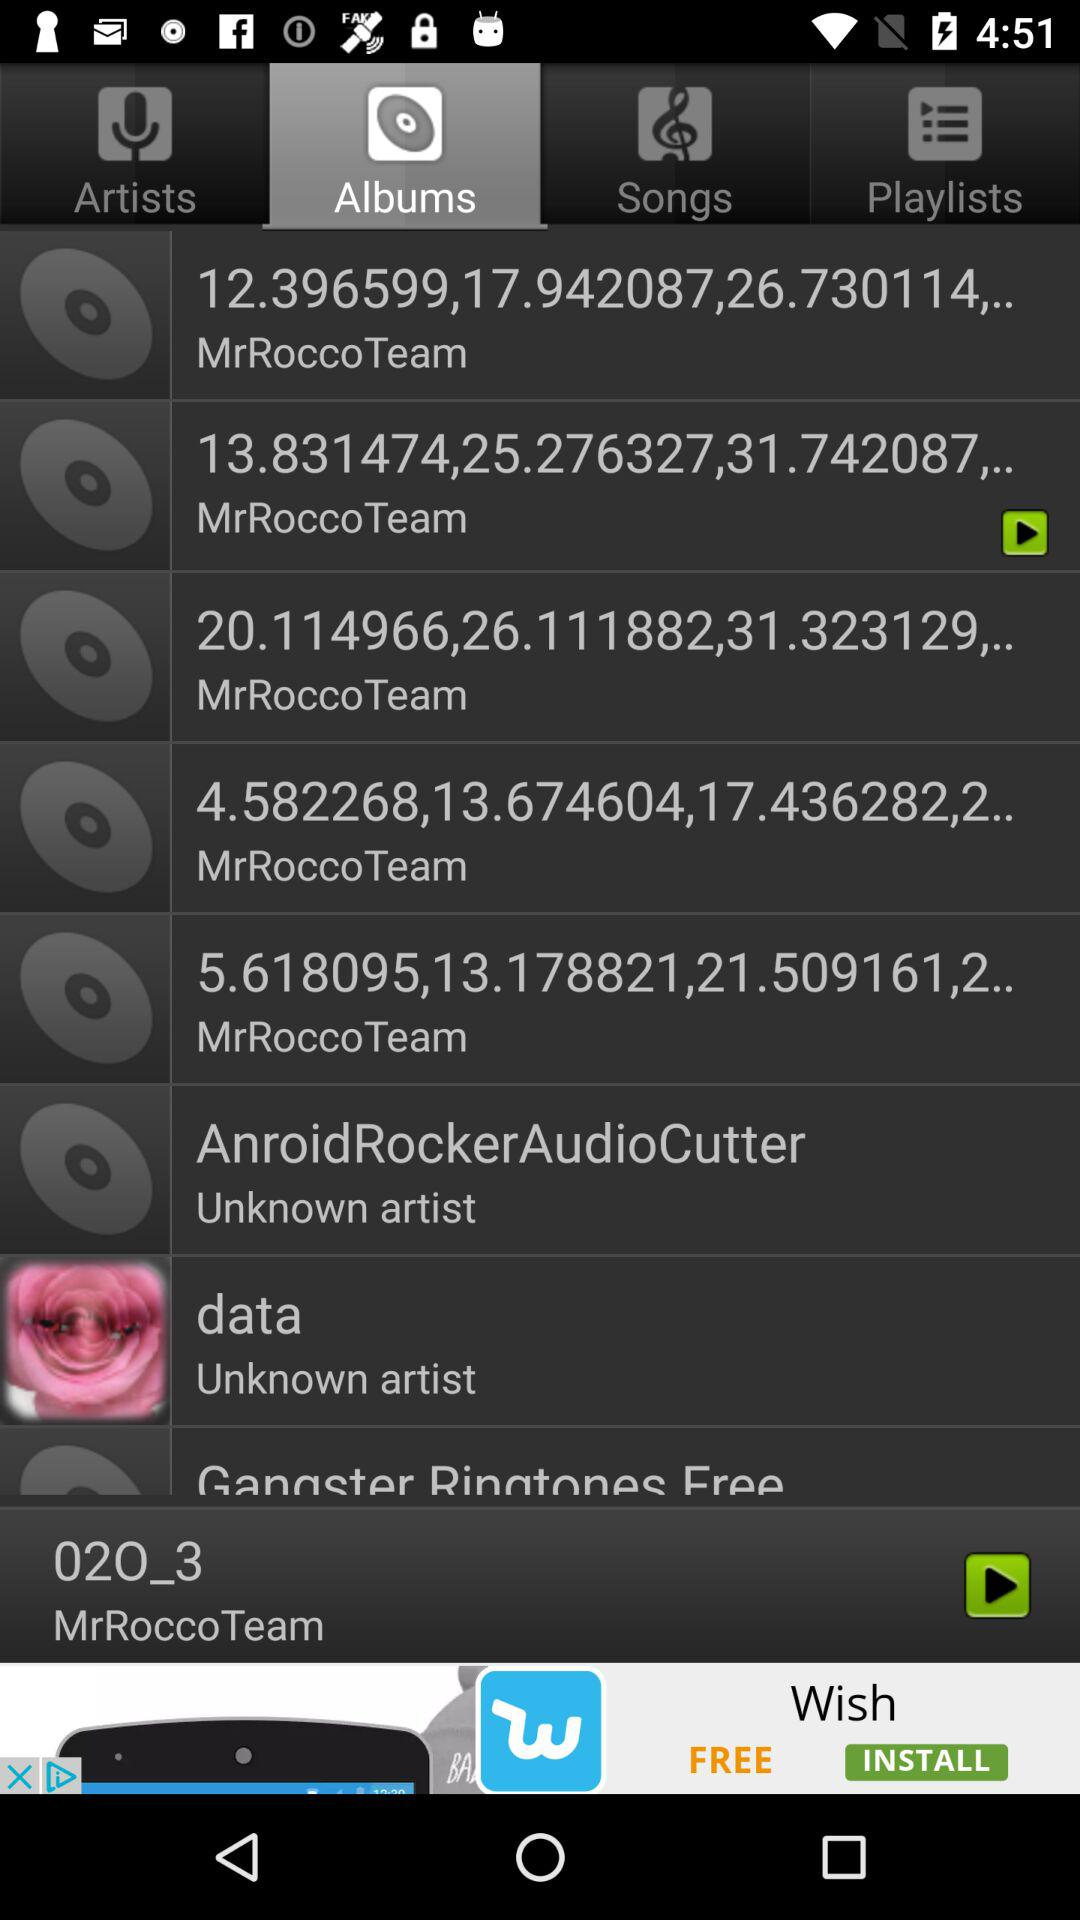What song was last played? The song that was last played is "02O_3". 